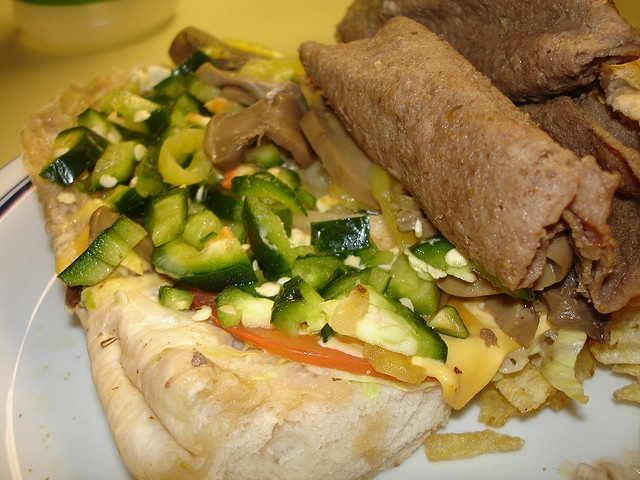Describe the objects in this image and their specific colors. I can see various objects in this image with different colors. 